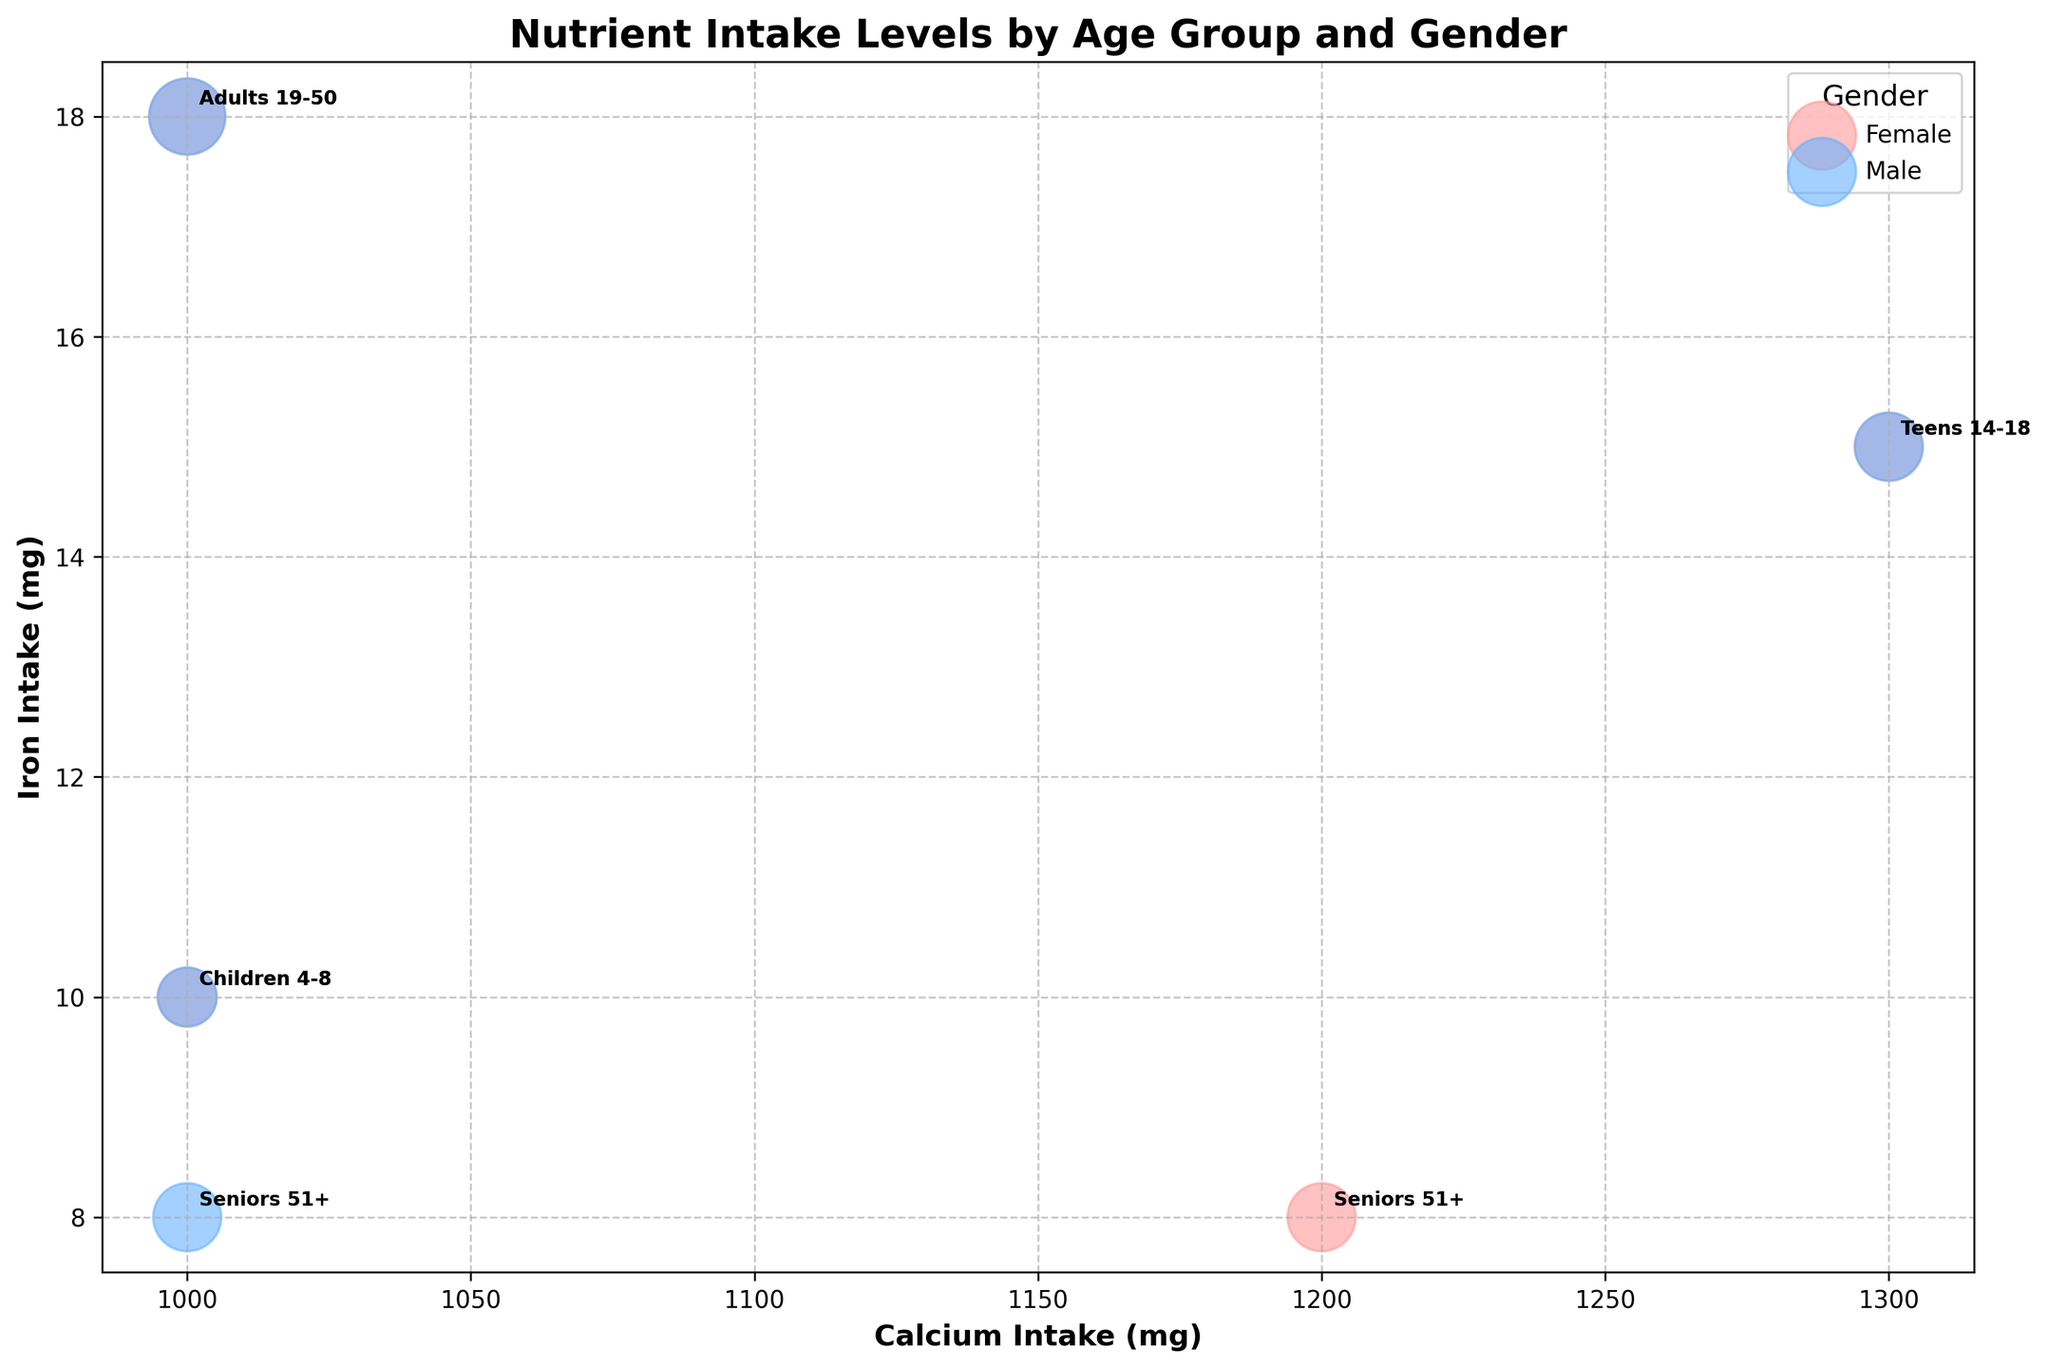What is the title of the figure? The title is usually located at the top of the figure and is meant to give a summary of what the figure represents. In this case, it's clearly stated to summarize the visualized data.
Answer: Nutrient Intake Levels by Age Group and Gender Which demographic group has the highest bubble size? Bubble size indicates the relative importance or magnitude. From the plot, "Adults 19-50" has the largest bubble size, which corresponds to 50.
Answer: Adults 19-50 How many distinct age groups are represented in the figure? By counting the number of unique age groups annotated in the figure, we can determine the number of distinct age groups.
Answer: Four (Children 4-8, Teens 14-18, Adults 19-50, Seniors 51+) Which gender has bubbles with a higher average calcium intake? By examining the positions of the bubbles along the x-axis (Calcium Intake) and comparing the general trend for both genders, we can identify which has a higher average. Comparing the placements shows that it's quite even for most values.
Answer: Both are similar Which demographic group has the highest iron intake, and what is the value? By looking at the y-axis (Iron Intake) and identifying the highest point, we can check which demographic group it corresponds to. It belongs to "Adults 19-50, Female" at 18 mg.
Answer: Adults 19-50, Female, 18 mg What is the difference in protein intake between "Teens 14-18, Male" and "Teens 14-18, Female"? We find the protein intake (g) values for both subgroups and subtract the female value from the male value. The male intake is 52 g and the female intake is 46 g, so 52 - 46 = 6.
Answer: 6 g For the same gender, how does the iron intake of "Children 4-8" compare to "Seniors 51+"? By comparing the positions of bubbles for "Children 4-8" and "Seniors 51+" of the same gender along the y-axis (Iron Intake), we can determine which has a higher value. Both groups show "8 mg" for "Seniors 51+" and "10 mg" for "Children 4-8".
Answer: Children 4-8 has higher iron intake Which age group and gender combination has the highest vitamin C intake? We need to examine possible annotations alongside the highest bubble along the x-axis (Vitamin C), looking for the gender with the highest point. "Adults 19-50, Male" has the highest intake of 90 mg.
Answer: Adults 19-50, Male How does the average calcium intake for males compare with the average calcium intake for females? Summing up the calcium intake values for each gender and dividing by the number of data points (4 for each gender) gives the average. The average for both males and females is 1125 mg, showing similarity.
Answer: Both are similar Of all groups, which demographic group could be considered to have balanced nutrient intake across calcium, iron, and protein? Identifying the group closest to the center of the bubble chart with consistent nutrient intake across three key markers (calcium, iron, and protein). “Adults 19-50” groups appear the most balanced due to central placement without extremely high or low deviations.
Answer: Adults 19-50 